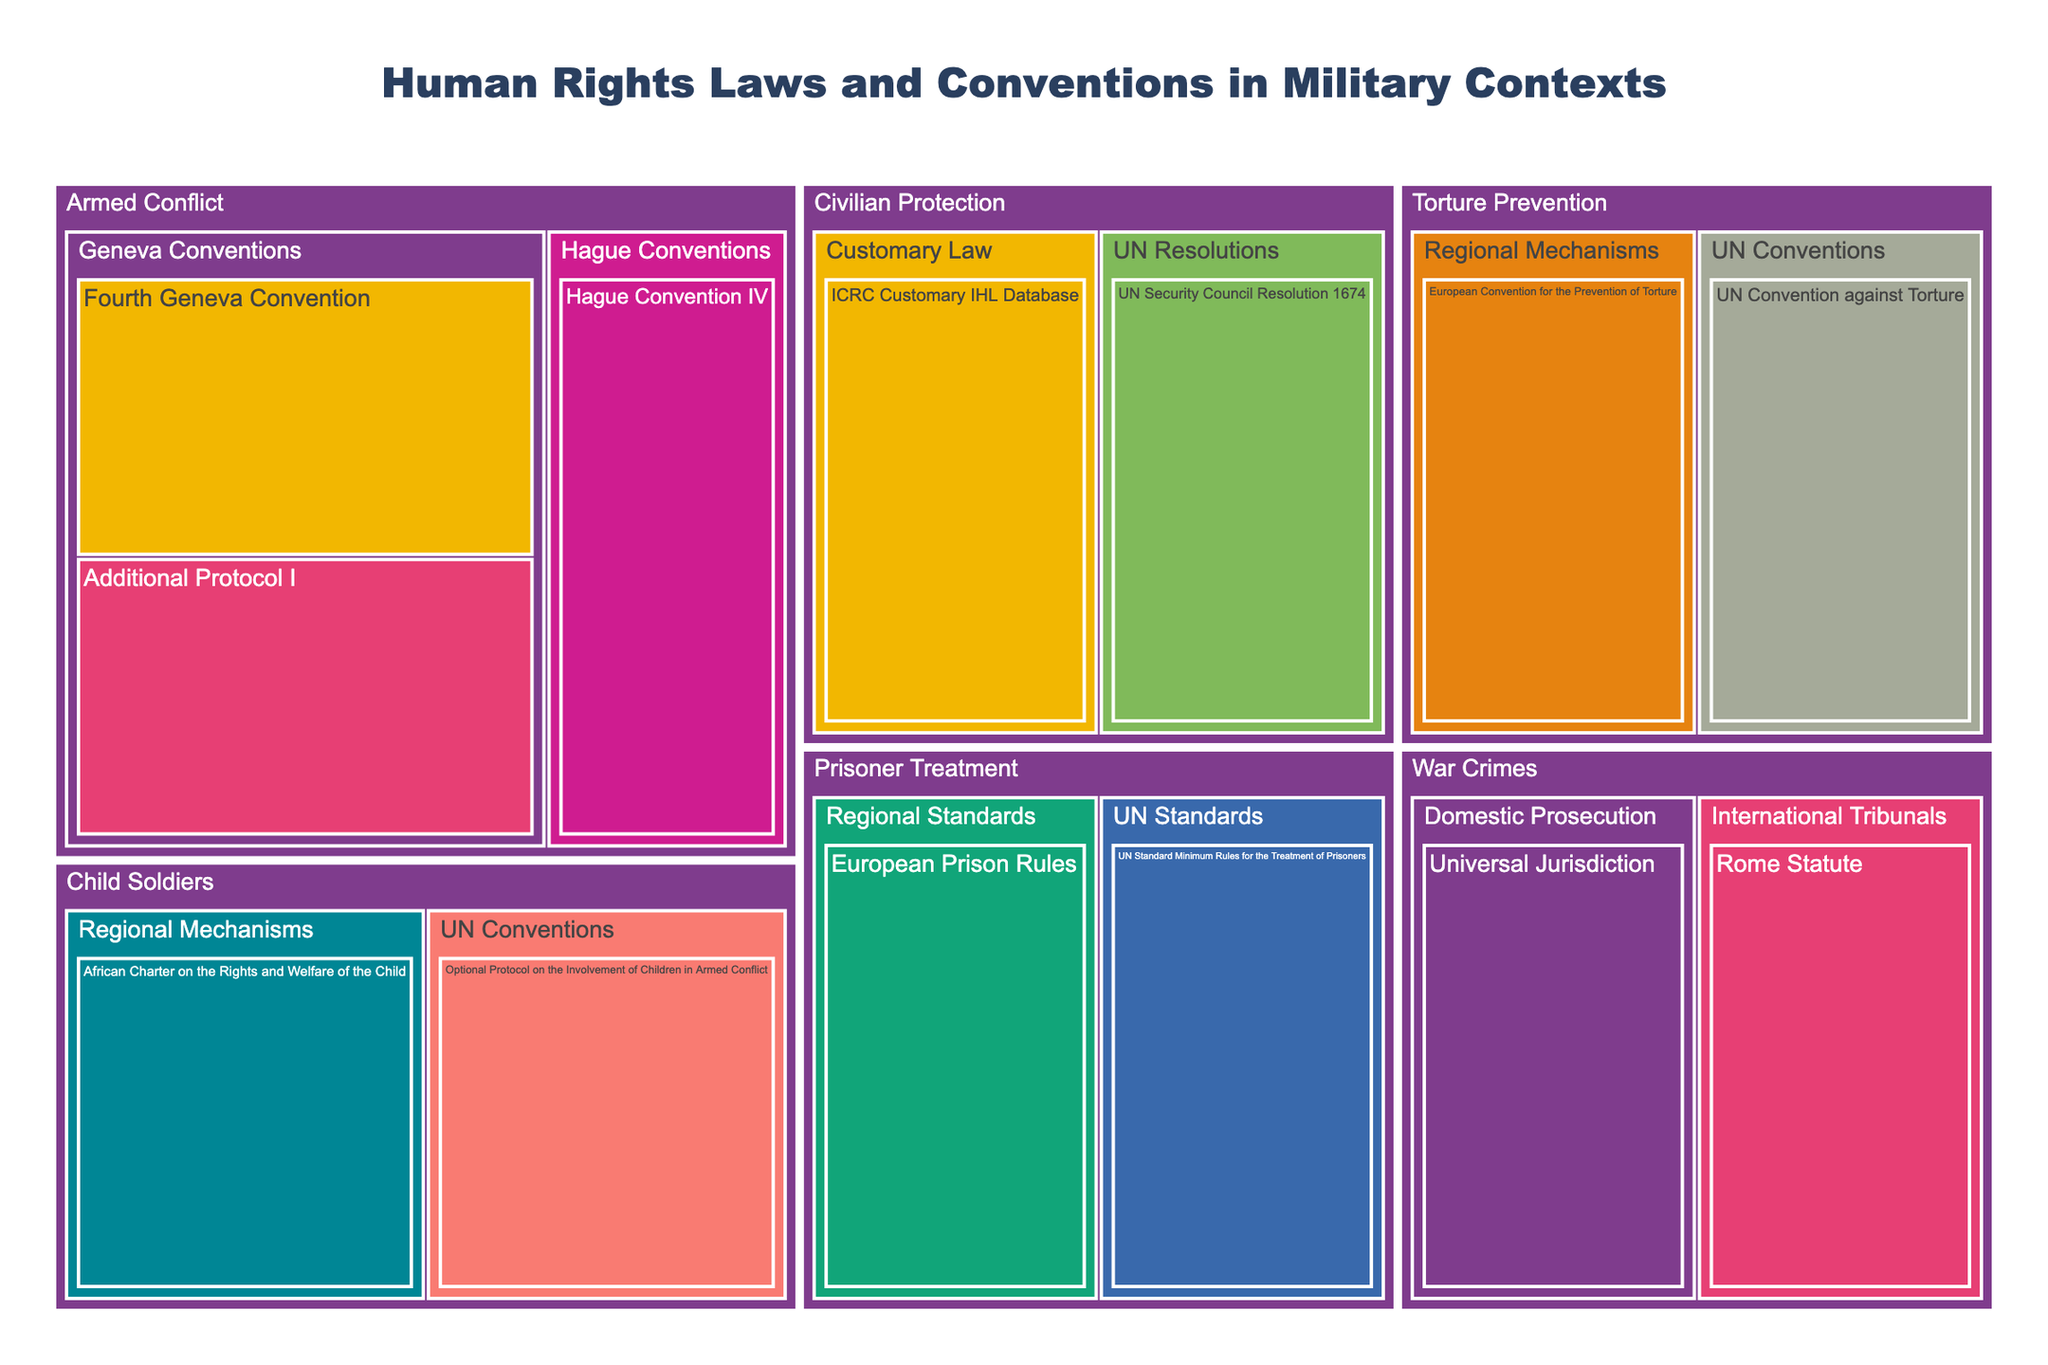What is the title of the treemap? The title is prominently displayed at the top of the treemap in a larger and bold font.
Answer: Human Rights Laws and Conventions in Military Contexts Which enforcement mechanism appears most frequently in the treemap? By looking through the treemap, the enforcement mechanism associated with the highest number of subcategories and conventions can be determined.
Answer: International Committee of the Red Cross How many conventions are listed under the 'Armed Conflict' category? The 'Armed Conflict' category contains several conventions under its subcategories. Counting each one gives the total number.
Answer: 3 Which enforcement mechanism is associated with the 'UN Convention against Torture'? The enforcement mechanism for each convention is shown in the hover data of the treemap. When hovering over 'UN Convention against Torture', the enforcement mechanism is displayed.
Answer: Committee Against Torture How many categories are displayed in the treemap? Categories are the highest-level groupings in the treemap. Simply count the unique categories present in the tree structure.
Answer: 5 Which subcategory has conventions enforced by the European Court of Human Rights? By checking the treemap's hierarchy, under each subcategory, the enforcement mechanisms are displayed. Locate the enforcement by the European Court of Human Rights.
Answer: Regional Standards In the 'Child Soldiers' category, which enforcement mechanism is used for regional mechanisms? The 'Child Soldiers' category has subcategories, and by checking the regional mechanisms section, the associated enforcement mechanism can be identified.
Answer: African Committee of Experts on the Rights and Welfare of the Child Which category includes the 'UN Security Council Resolution 1674' and who enforces it? This will involve locating the convention named 'UN Security Council Resolution 1674' in the treemap and noting its enforcement mechanism in the hover data.
Answer: Civilian Protection, UN Security Council How many enforcement mechanisms are utilized across all conventions in the treemap? By identifying each distinct enforcement mechanism listed in the treemap, and counting them without repetition, the total number can be determined.
Answer: 9 